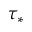<formula> <loc_0><loc_0><loc_500><loc_500>\tau _ { * }</formula> 